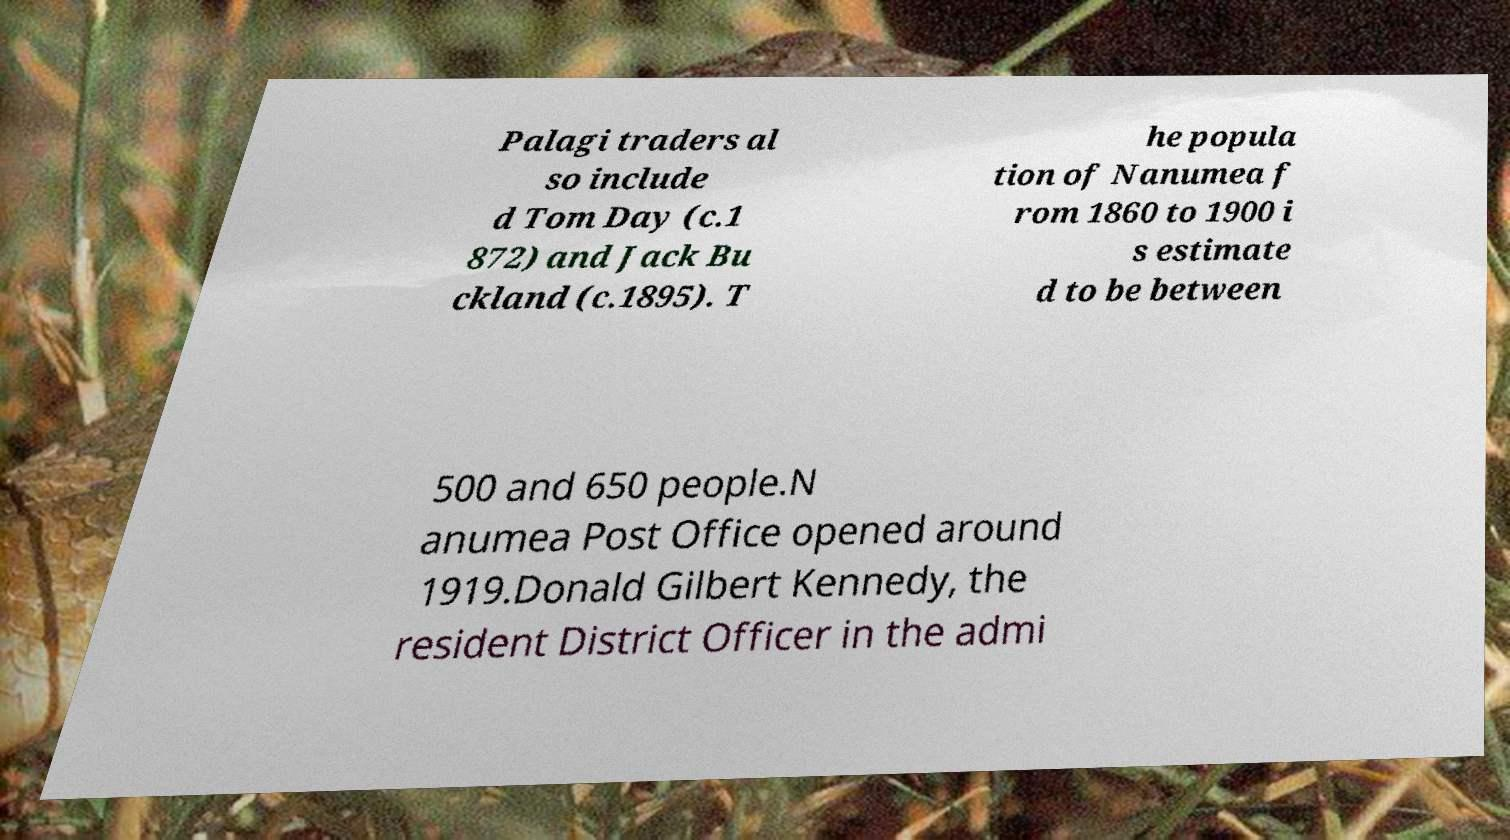Can you accurately transcribe the text from the provided image for me? Palagi traders al so include d Tom Day (c.1 872) and Jack Bu ckland (c.1895). T he popula tion of Nanumea f rom 1860 to 1900 i s estimate d to be between 500 and 650 people.N anumea Post Office opened around 1919.Donald Gilbert Kennedy, the resident District Officer in the admi 